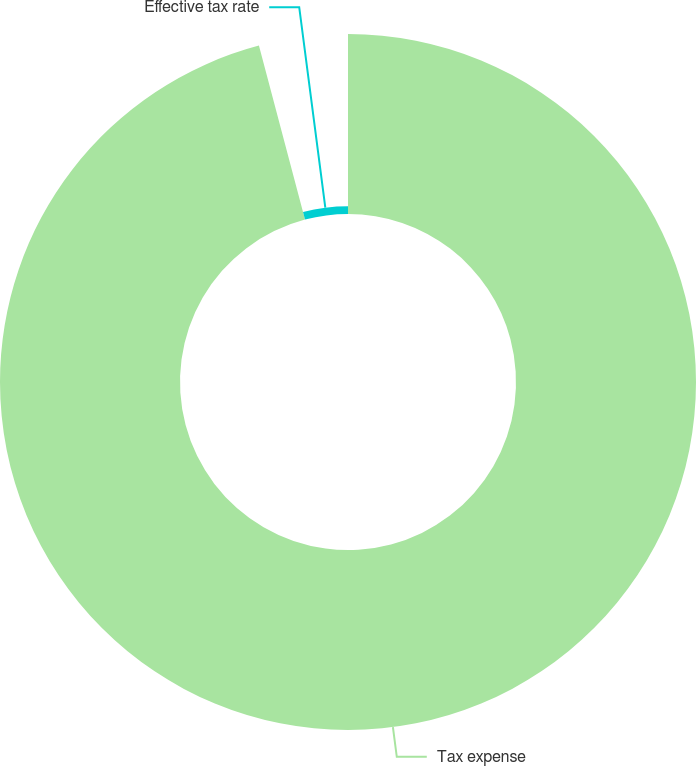Convert chart. <chart><loc_0><loc_0><loc_500><loc_500><pie_chart><fcel>Tax expense<fcel>Effective tax rate<nl><fcel>95.88%<fcel>4.12%<nl></chart> 